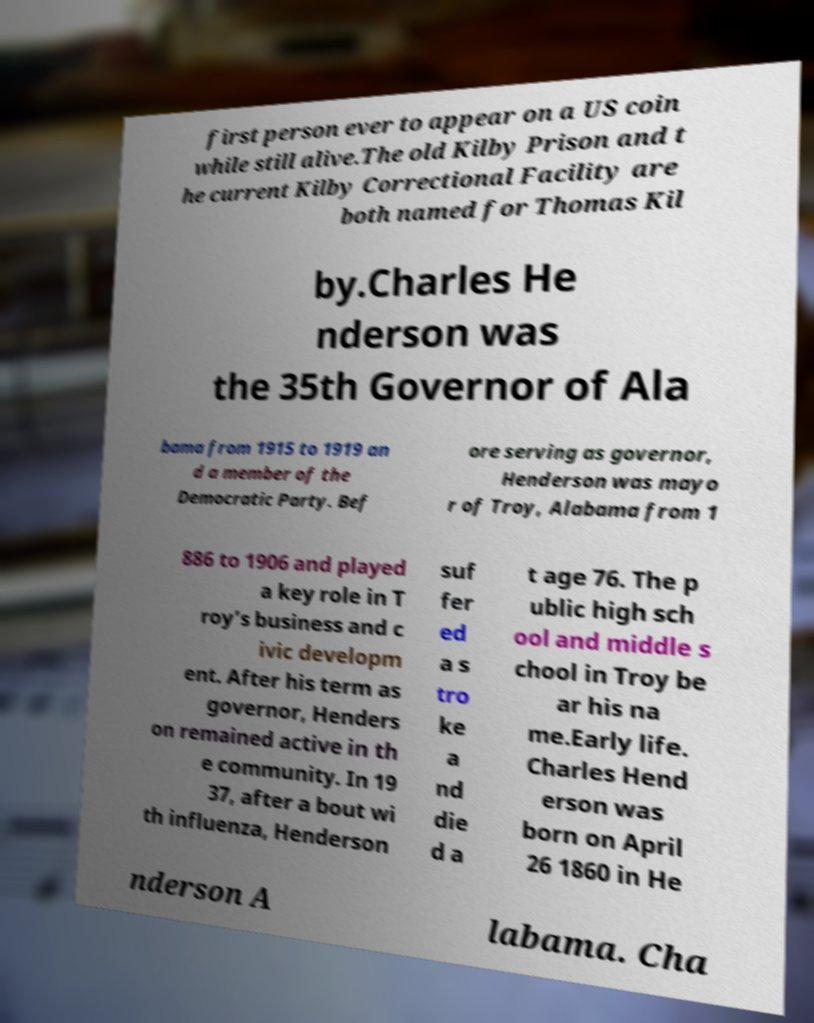Could you extract and type out the text from this image? first person ever to appear on a US coin while still alive.The old Kilby Prison and t he current Kilby Correctional Facility are both named for Thomas Kil by.Charles He nderson was the 35th Governor of Ala bama from 1915 to 1919 an d a member of the Democratic Party. Bef ore serving as governor, Henderson was mayo r of Troy, Alabama from 1 886 to 1906 and played a key role in T roy’s business and c ivic developm ent. After his term as governor, Henders on remained active in th e community. In 19 37, after a bout wi th influenza, Henderson suf fer ed a s tro ke a nd die d a t age 76. The p ublic high sch ool and middle s chool in Troy be ar his na me.Early life. Charles Hend erson was born on April 26 1860 in He nderson A labama. Cha 